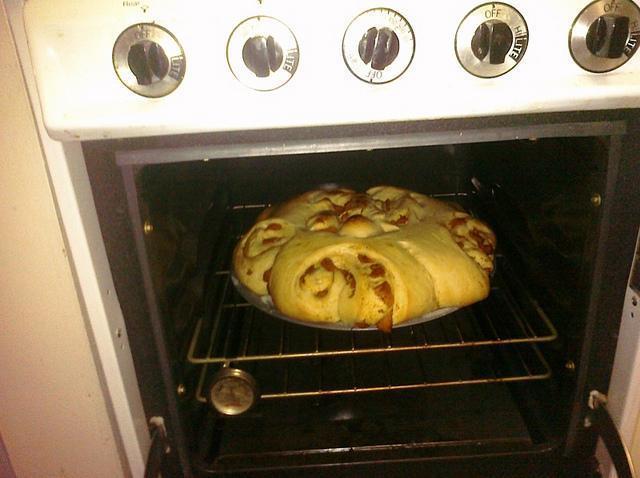Is the statement "The pizza is inside the oven." accurate regarding the image?
Answer yes or no. Yes. 